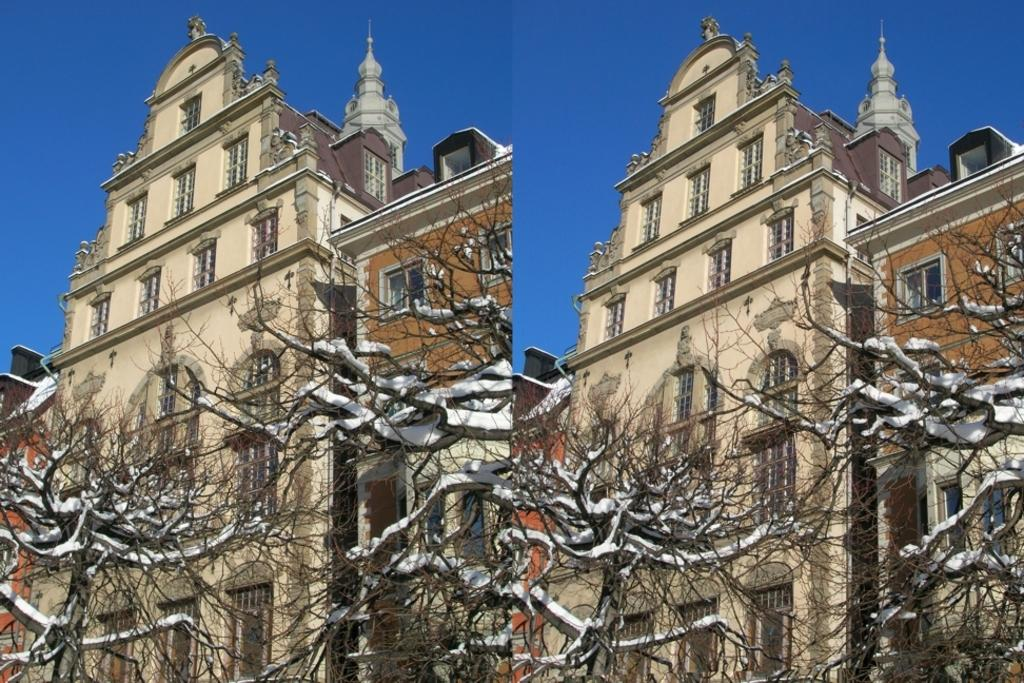What is the composition of the image? The image is a collage of two images. What type of natural elements can be seen in the image? Trees are present in the image. What type of structure is visible in the image? There is a cream-colored building in the image. What is the weather condition in the image? There is snow on the trees, indicating a cold weather condition. What is visible in the background of the image? The sky is visible in the background of the image. Can you see a plane flying through the fog in the image? There is no plane or fog present in the image. What type of creature is sleeping on the bed in the image? There is no bed or creature present in the image. 